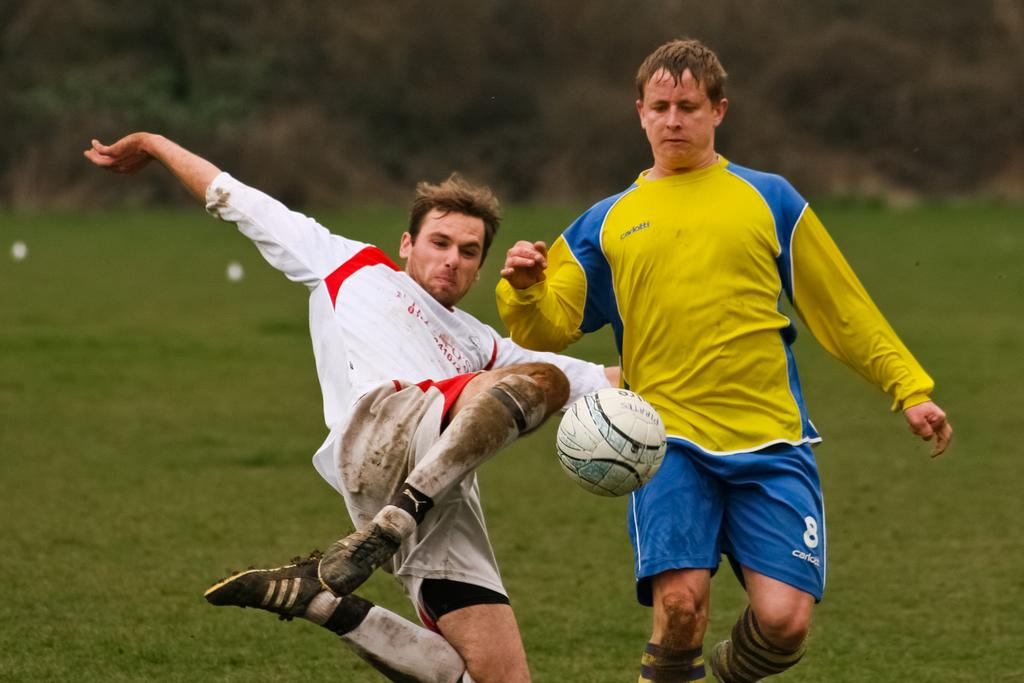How many people are in the image? There are two men in the image. What are the men doing in the image? The men are playing with a football. What is the surface they are playing on? The ground is filled with grass. What type of book can be seen in the image? There is no book present in the image. Can you describe the fish swimming in the image? There are no fish present in the image. 